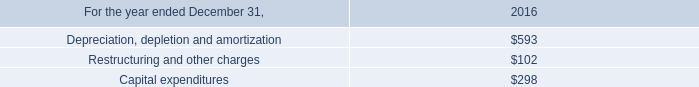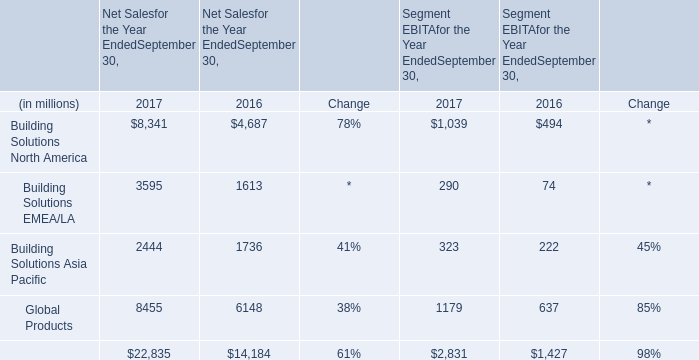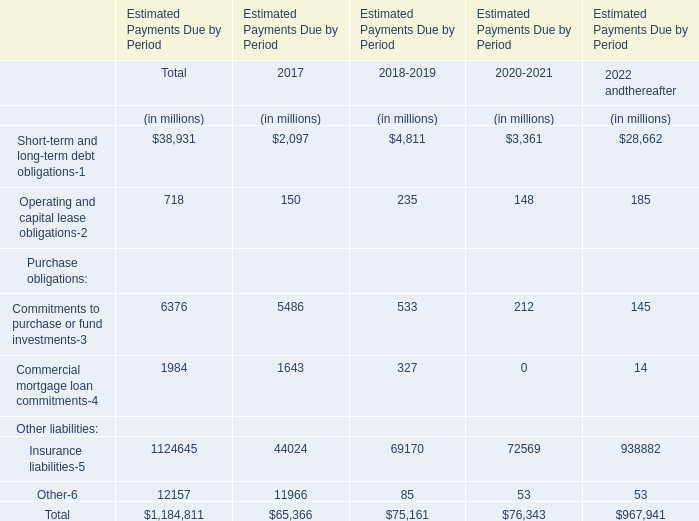considering the asr agreement , what will be the total value associated with the repurchase program of common stock , in millions of dollars? 
Computations: (700 * 32)
Answer: 22400.0. 